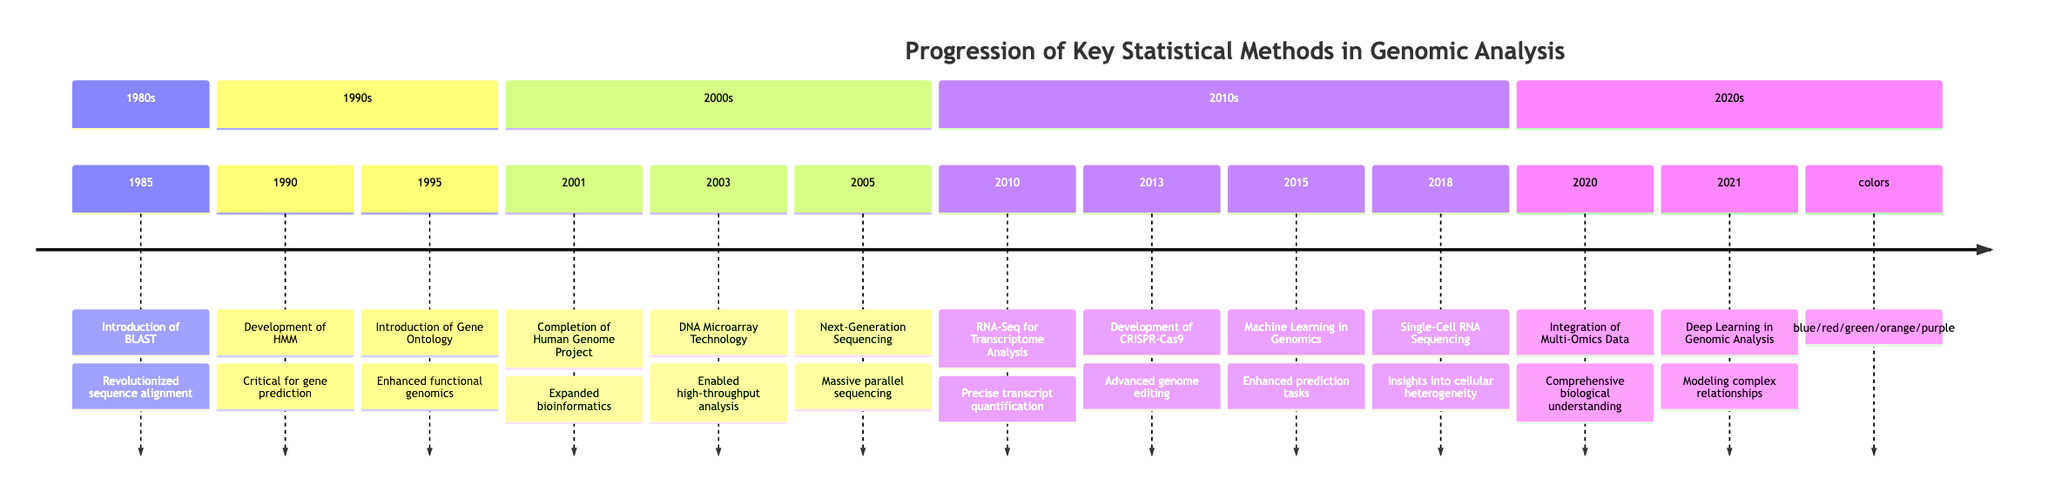What year was the completion of the Human Genome Project? The timeline indicates that the completion of the Human Genome Project occurred in the year 2001.
Answer: 2001 What statistical method was introduced in 1995? Referring to the timeline, the development introduced in 1995 is Gene Ontology.
Answer: Gene Ontology How many key developments occurred in the 2010s? By counting the entries listed between 2010 and 2019 on the timeline, there are four key developments.
Answer: 4 What technology was adopted in 2003? The timeline states that DNA Microarray Technology was adopted in 2003.
Answer: DNA Microarray Technology Which method emerged in 2015 that was related to artificial intelligence? The timeline mentions the application of Machine Learning in Genomics as the method related to artificial intelligence that emerged in 2015.
Answer: Machine Learning What was the main focus of the development in 2018? In 2018, the timeline indicates that the focus was on Single-Cell RNA Sequencing, which provided insights into cellular heterogeneity.
Answer: Single-Cell RNA Sequencing How did the introduction of RNA-Seq in 2010 influence genomic analysis? The timeline describes RNA-Seq as a method that offered precise and accurate quantification of transcript levels, necessitating refined statistical approaches for transcriptomics, indicating its significant influence.
Answer: Refined statistical approaches for transcriptomics Which development followed the emergence of Next-Generation Sequencing in 2005? Looking at the timeline, the development that followed in 2010 was the introduction of RNA-Seq for Transcriptome Analysis.
Answer: RNA-Seq for Transcriptome Analysis What can be inferred about the trend of statistical methods from 1985 to 2021? When examining the timeline, it can be inferred that there has been a progressive advancement in statistical methods that have evolved alongside technological developments and increased data complexity in genomics.
Answer: Progressive advancement in statistical methods 